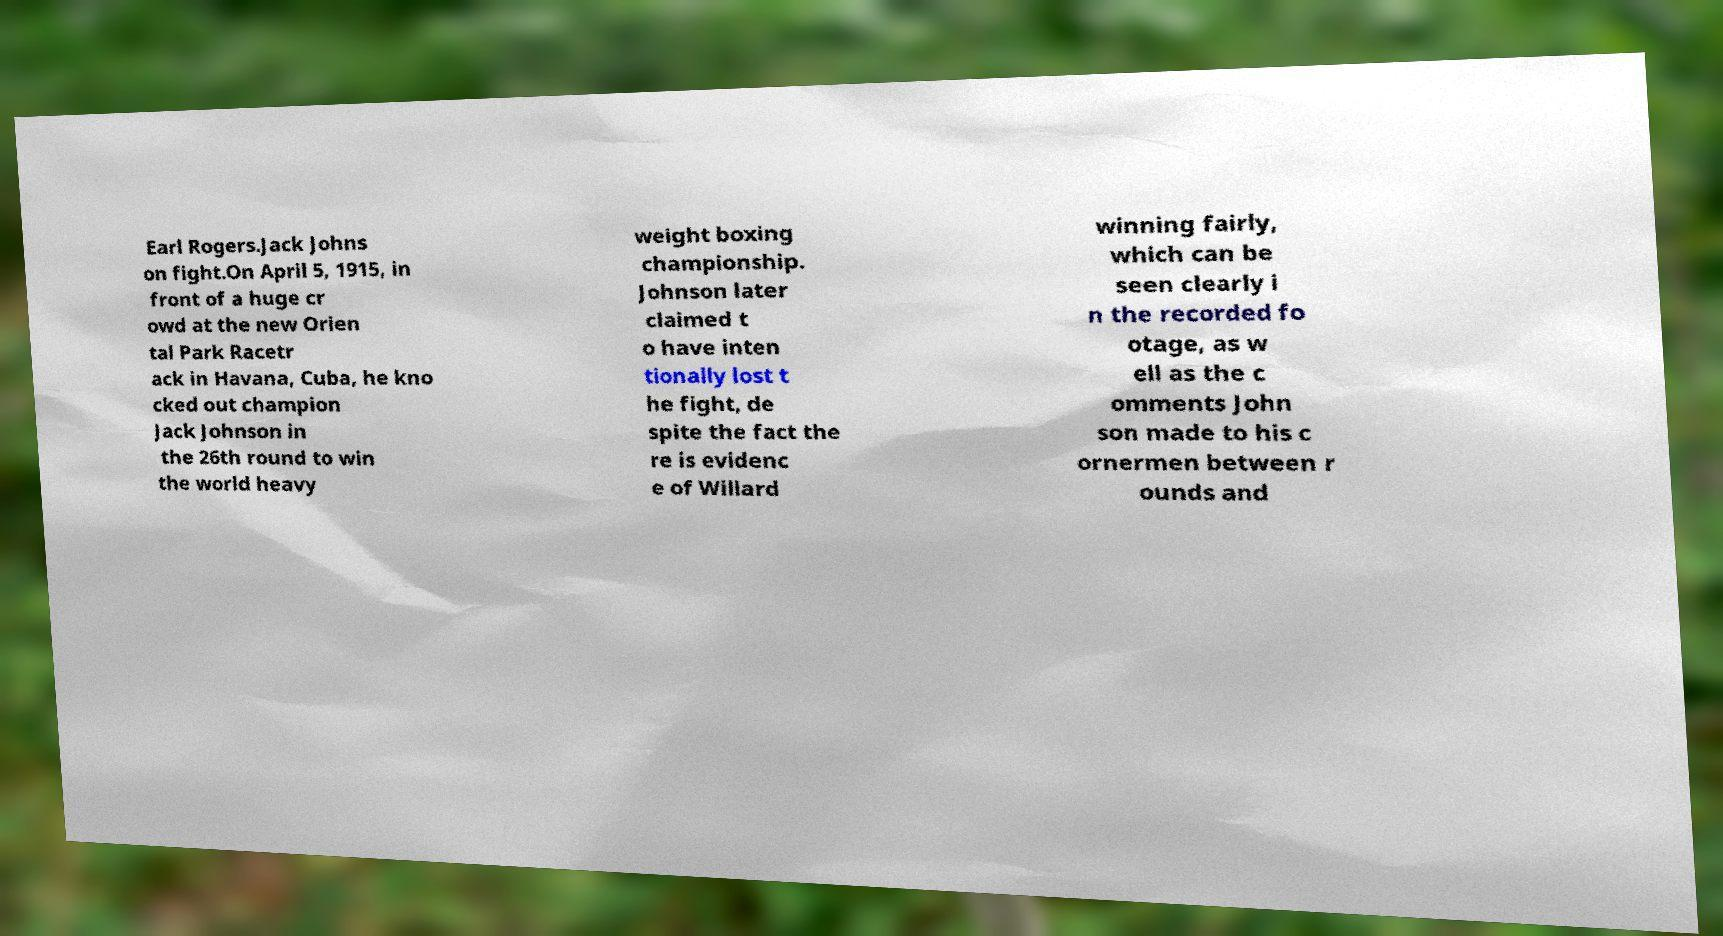There's text embedded in this image that I need extracted. Can you transcribe it verbatim? Earl Rogers.Jack Johns on fight.On April 5, 1915, in front of a huge cr owd at the new Orien tal Park Racetr ack in Havana, Cuba, he kno cked out champion Jack Johnson in the 26th round to win the world heavy weight boxing championship. Johnson later claimed t o have inten tionally lost t he fight, de spite the fact the re is evidenc e of Willard winning fairly, which can be seen clearly i n the recorded fo otage, as w ell as the c omments John son made to his c ornermen between r ounds and 